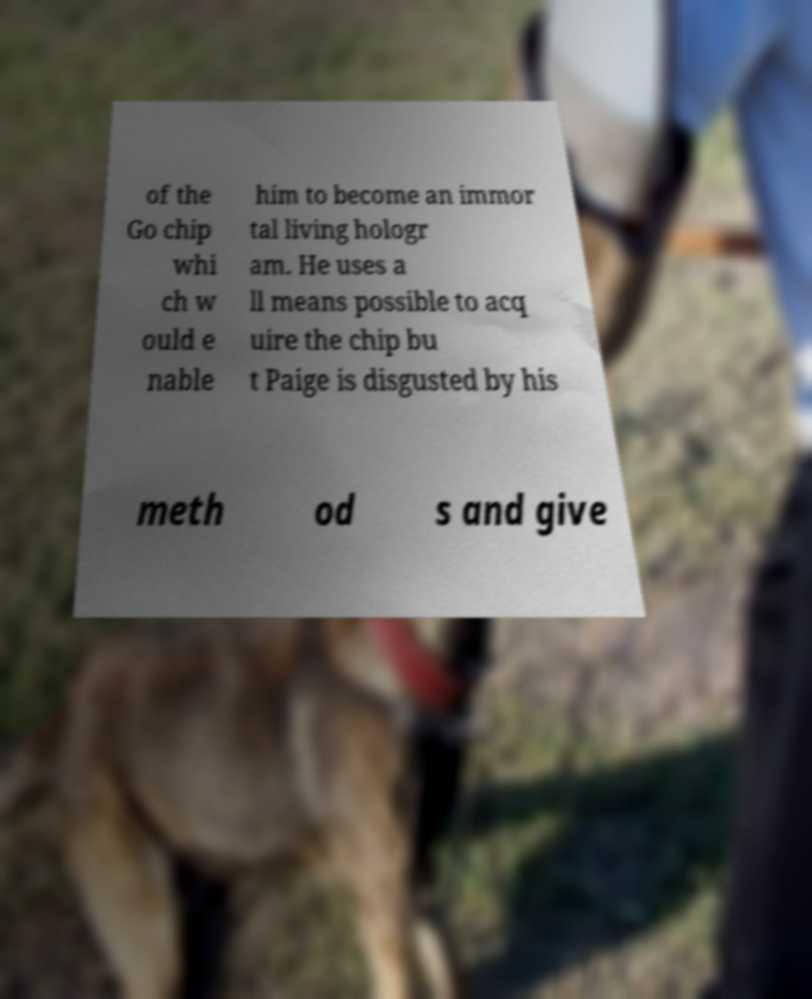I need the written content from this picture converted into text. Can you do that? of the Go chip whi ch w ould e nable him to become an immor tal living hologr am. He uses a ll means possible to acq uire the chip bu t Paige is disgusted by his meth od s and give 